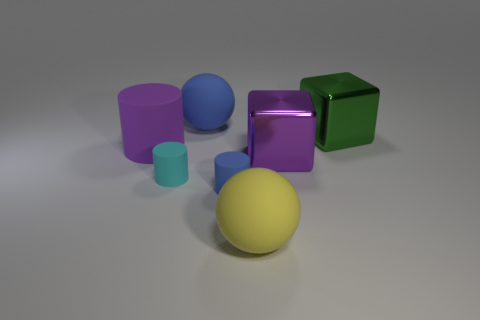Subtract 1 cylinders. How many cylinders are left? 2 Add 1 blue matte objects. How many objects exist? 8 Subtract 0 blue cubes. How many objects are left? 7 Subtract all cylinders. How many objects are left? 4 Subtract all matte cubes. Subtract all big green shiny blocks. How many objects are left? 6 Add 1 metal cubes. How many metal cubes are left? 3 Add 4 big blue things. How many big blue things exist? 5 